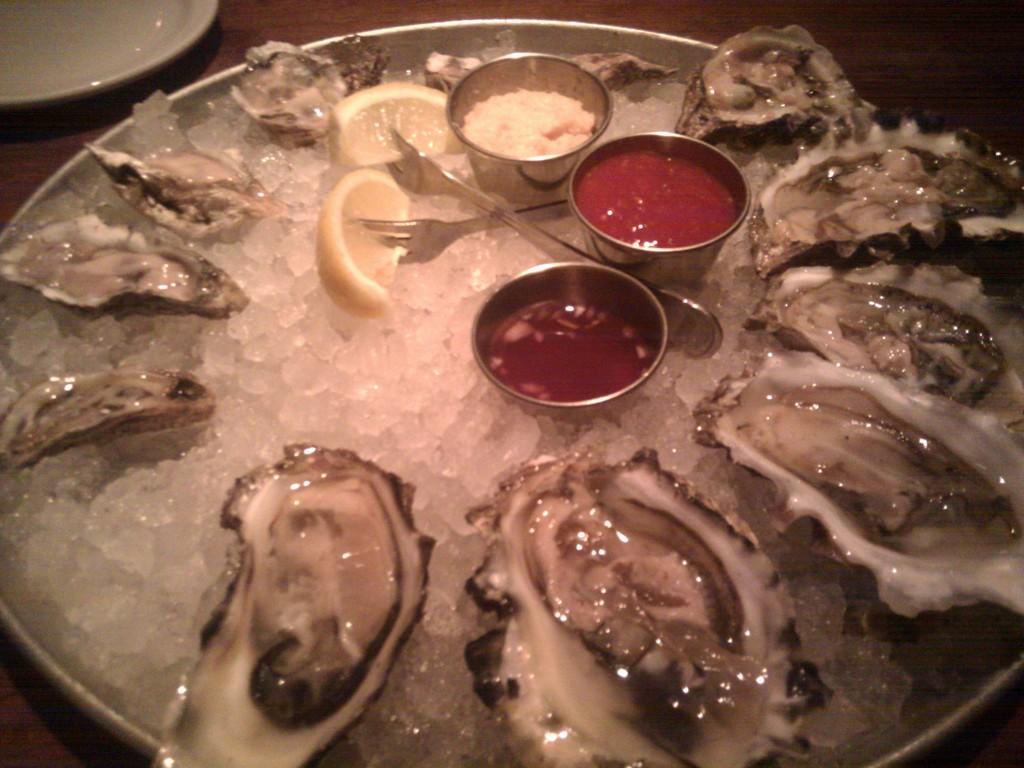Could you give a brief overview of what you see in this image? In the image we can see a table, on the table we can see some plates. In the plate we can see some food and forks. 